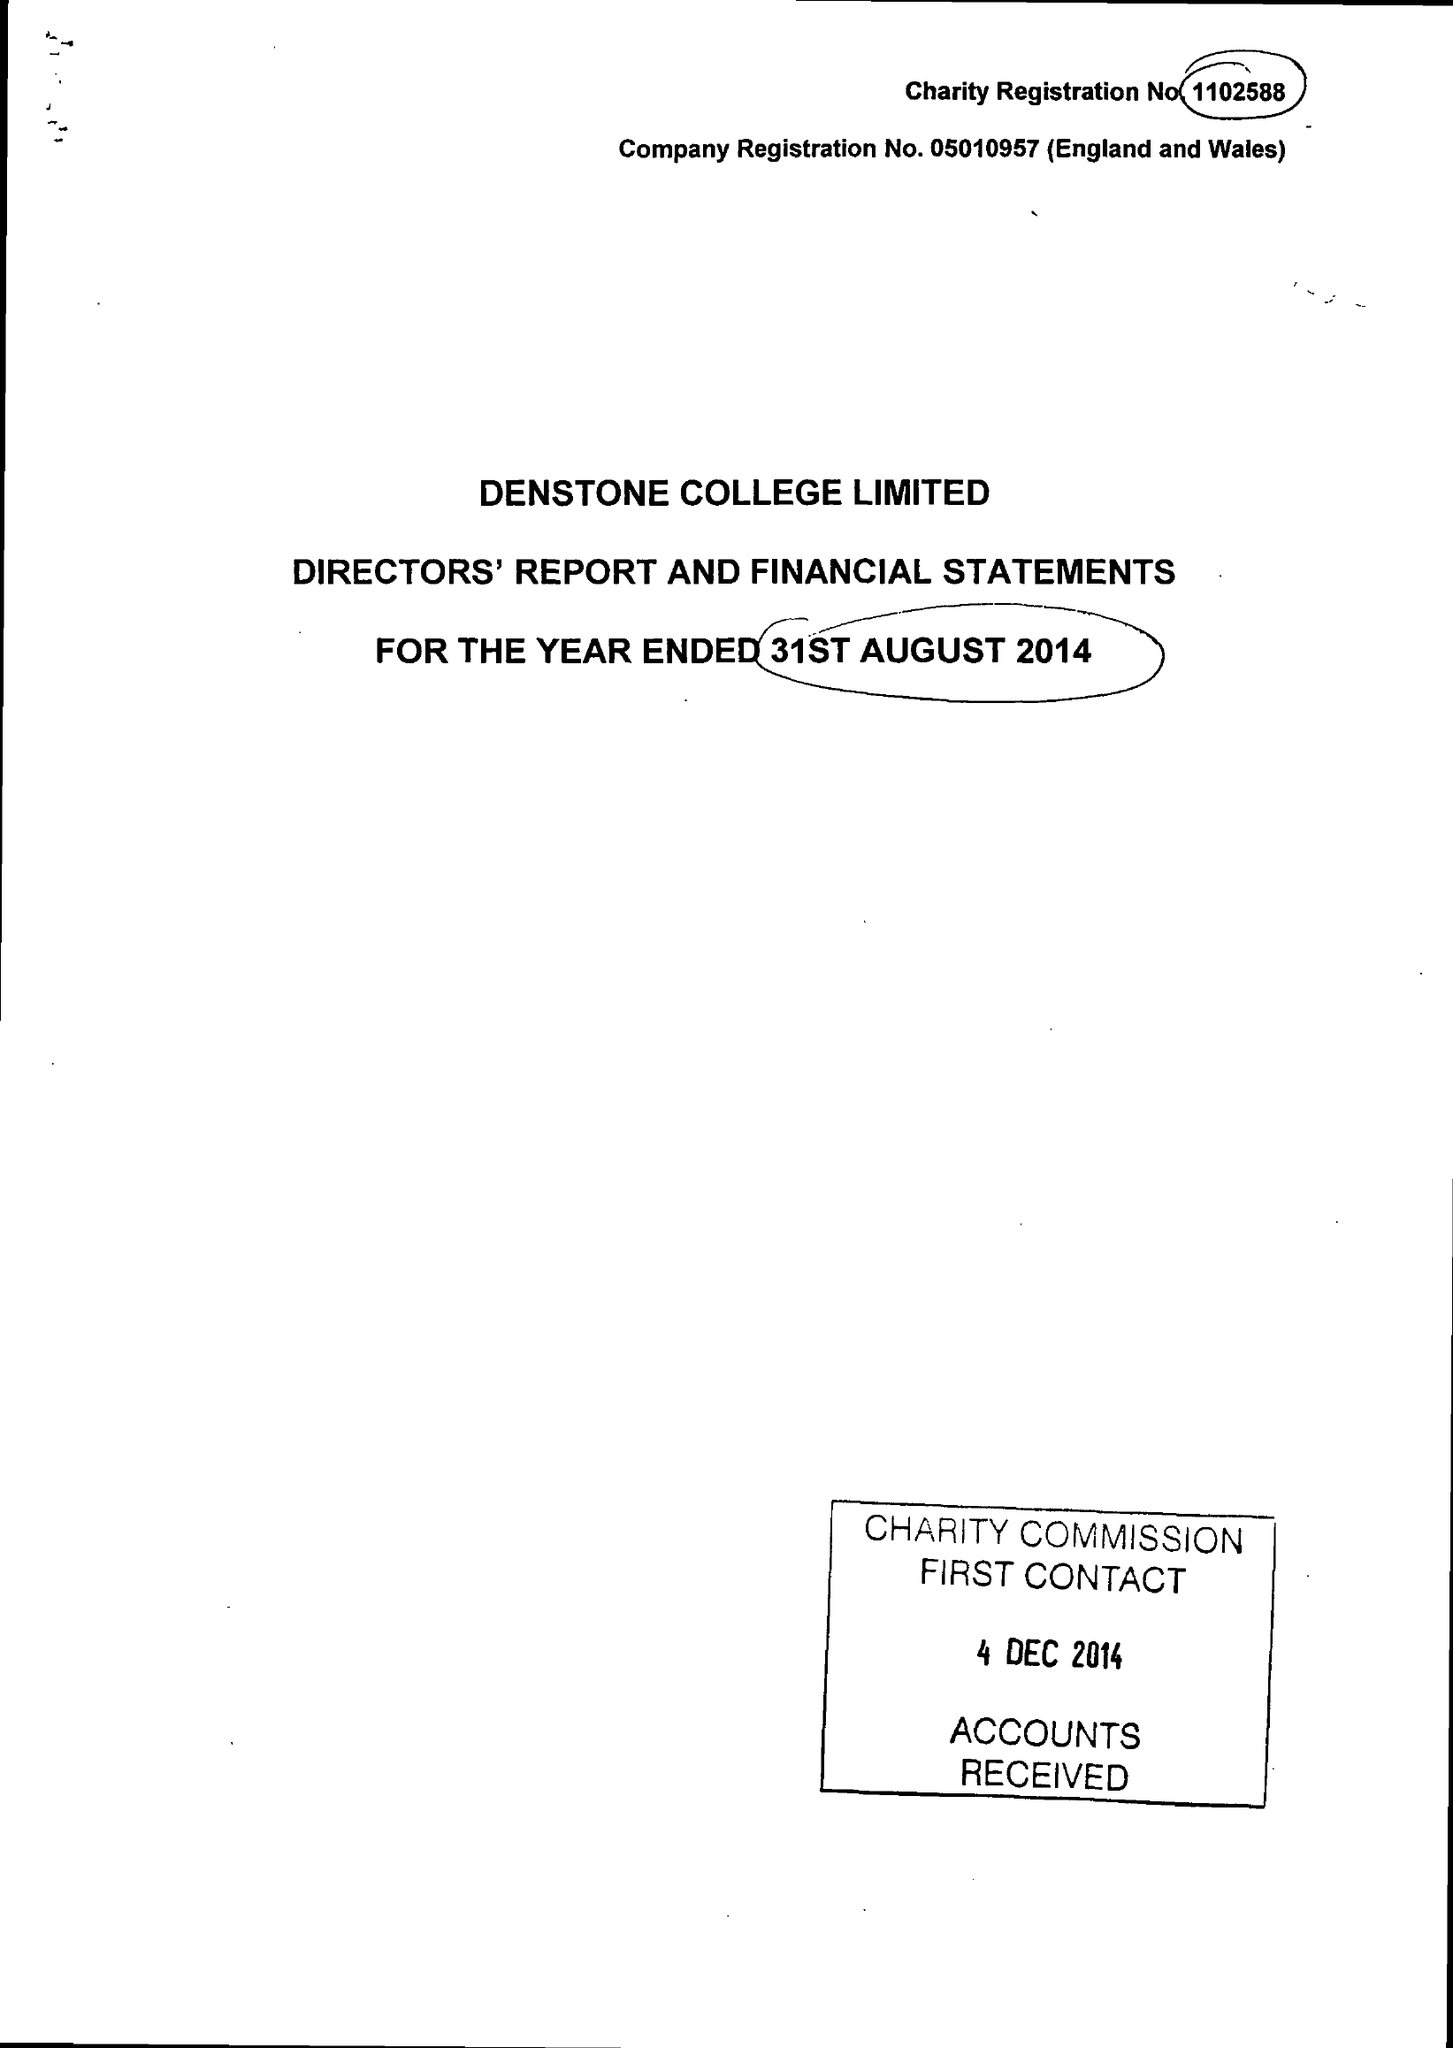What is the value for the income_annually_in_british_pounds?
Answer the question using a single word or phrase. 8944071.00 